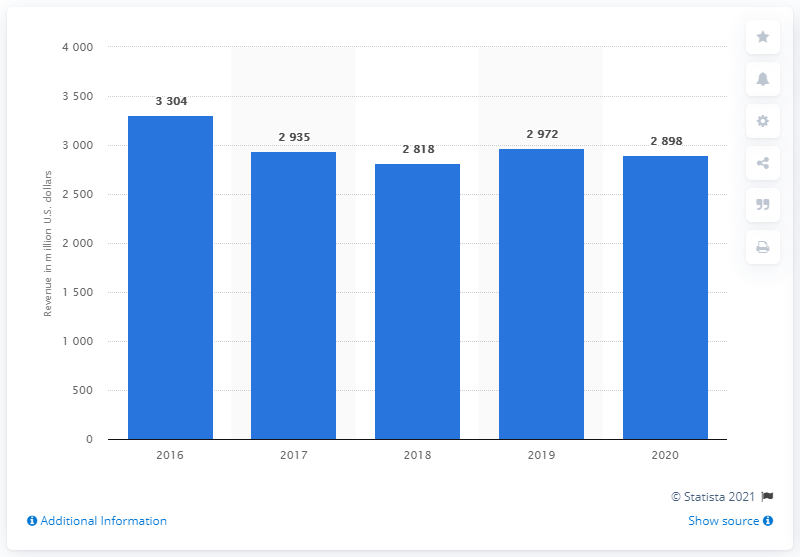Specify some key components in this picture. It is estimated that in 2020, Capri Holdings generated approximately 2898 million U.S. dollars in revenue. 